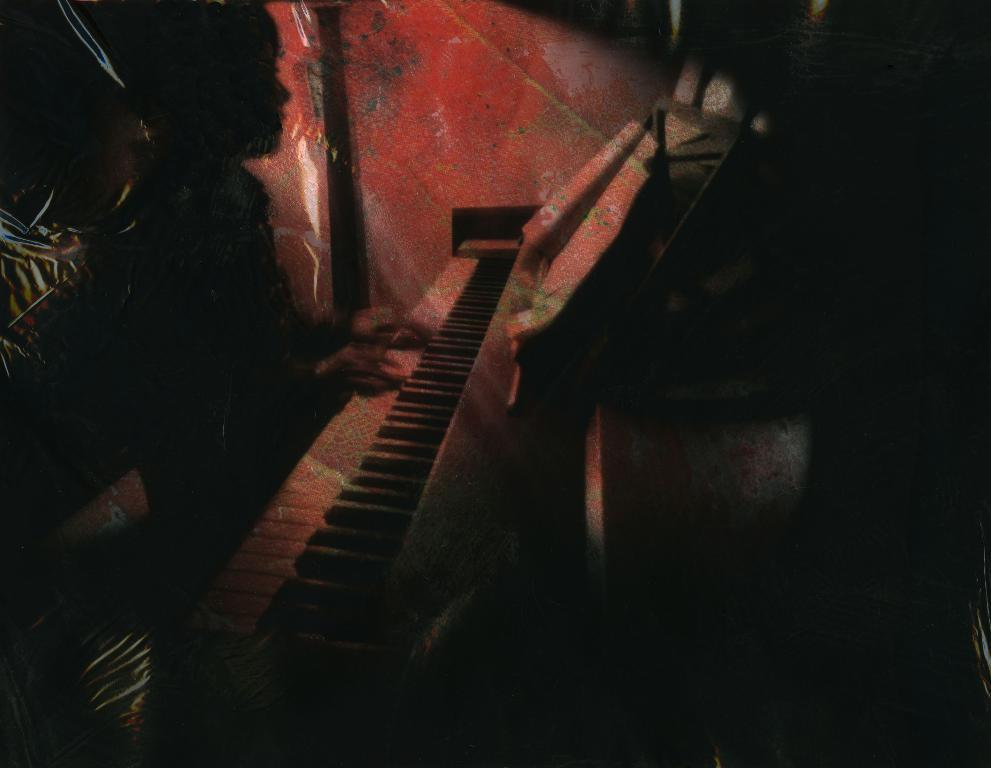What is the main subject of the image? There is a person in the image. What is the person doing in the image? The person is playing a keyboard. Can you describe the lighting in the image? The image is very dark. What type of goat can be seen playing a hammer in the image? There is no goat or hammer present in the image; it features a person playing a keyboard. 